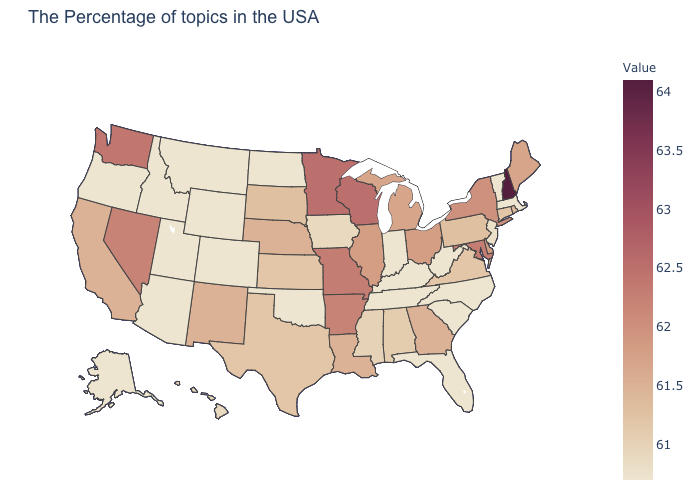Is the legend a continuous bar?
Short answer required. Yes. Among the states that border Maryland , which have the lowest value?
Give a very brief answer. West Virginia. Is the legend a continuous bar?
Give a very brief answer. Yes. Which states have the highest value in the USA?
Concise answer only. New Hampshire. 